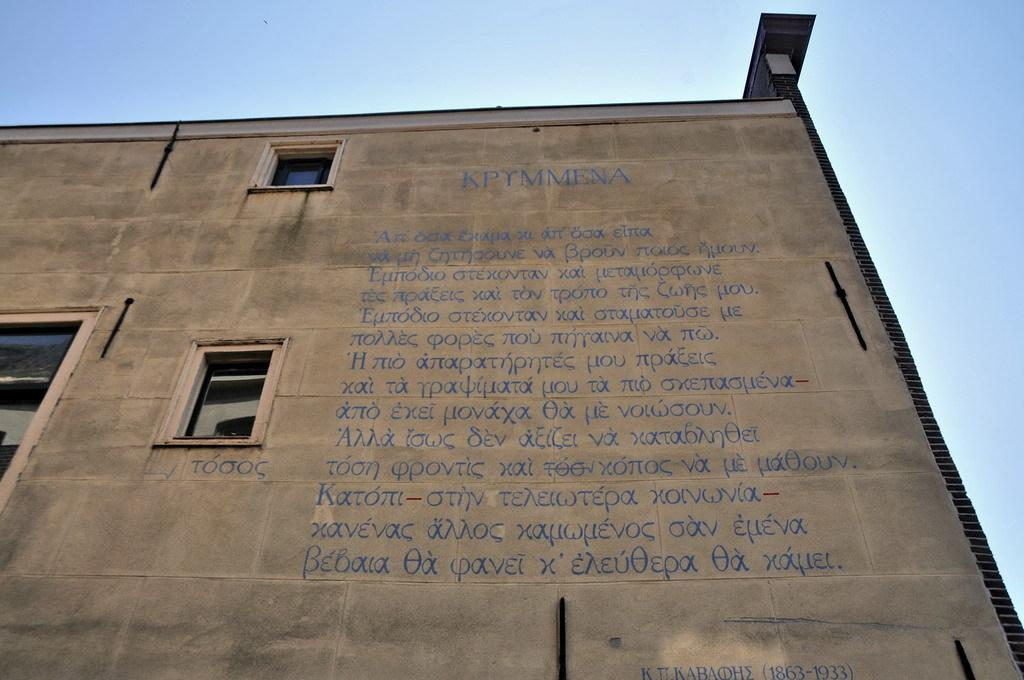What is the main structure in the image? There is a building in the image. What feature can be seen on the building? The building has windows. What is visible at the top of the image? The sky is visible at the top of the image. What type of yoke is attached to the building in the image? There is no yoke present in the image; it features a building with windows and a visible sky. 